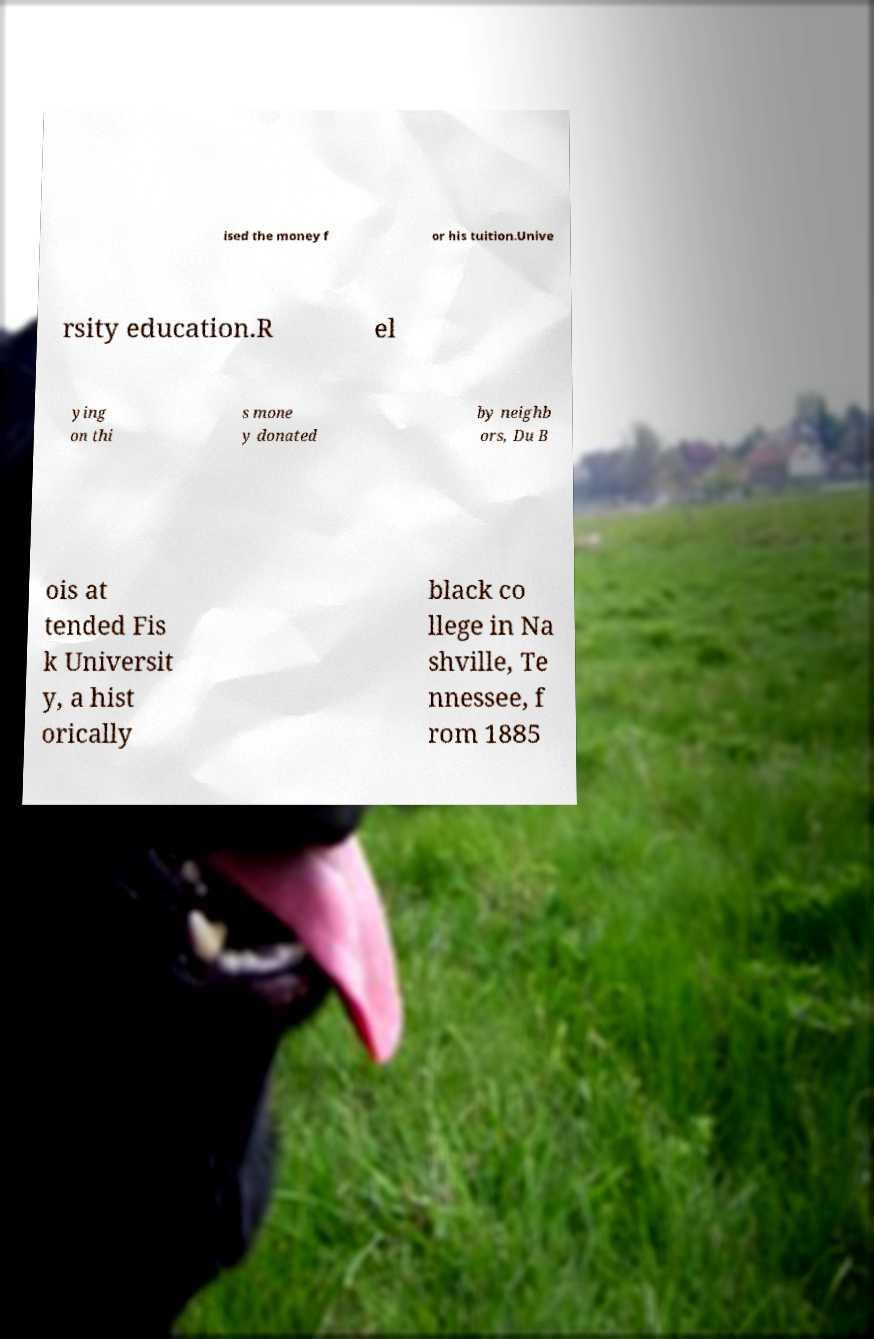There's text embedded in this image that I need extracted. Can you transcribe it verbatim? ised the money f or his tuition.Unive rsity education.R el ying on thi s mone y donated by neighb ors, Du B ois at tended Fis k Universit y, a hist orically black co llege in Na shville, Te nnessee, f rom 1885 